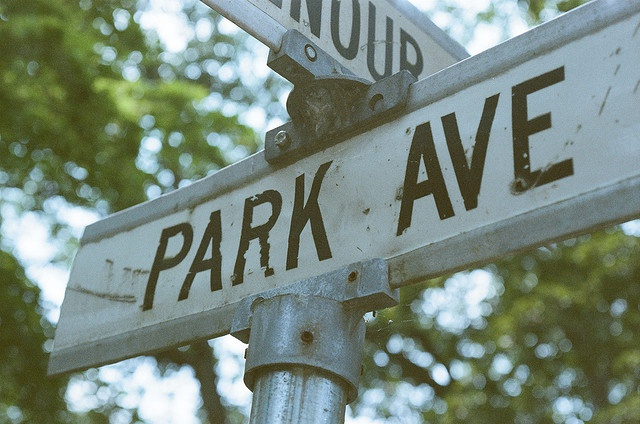Describe the objects in this image and their specific colors. I can see various objects in this image with different colors. 